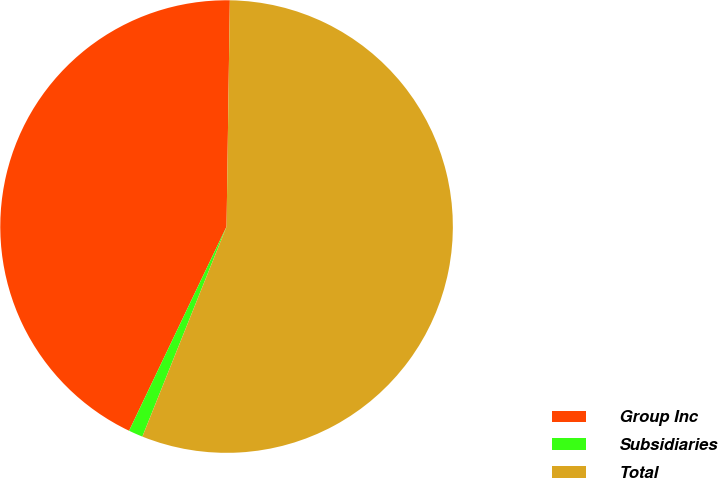<chart> <loc_0><loc_0><loc_500><loc_500><pie_chart><fcel>Group Inc<fcel>Subsidiaries<fcel>Total<nl><fcel>43.14%<fcel>1.02%<fcel>55.83%<nl></chart> 